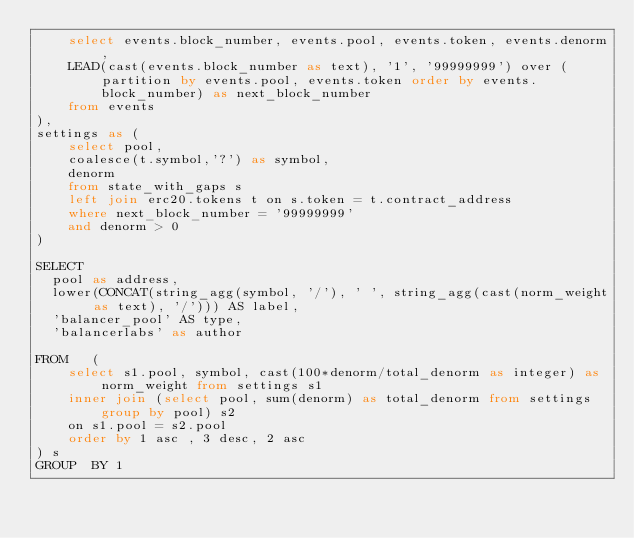<code> <loc_0><loc_0><loc_500><loc_500><_SQL_>    select events.block_number, events.pool, events.token, events.denorm,
    LEAD(cast(events.block_number as text), '1', '99999999') over (partition by events.pool, events.token order by events.block_number) as next_block_number
    from events 
), 
settings as (
    select pool, 
    coalesce(t.symbol,'?') as symbol, 
    denorm
    from state_with_gaps s
    left join erc20.tokens t on s.token = t.contract_address
    where next_block_number = '99999999'
    and denorm > 0
)

SELECT 
  pool as address, 
  lower(CONCAT(string_agg(symbol, '/'), ' ', string_agg(cast(norm_weight as text), '/'))) AS label,
  'balancer_pool' AS type,
  'balancerlabs' as author

FROM   (
    select s1.pool, symbol, cast(100*denorm/total_denorm as integer) as norm_weight from settings s1
    inner join (select pool, sum(denorm) as total_denorm from settings group by pool) s2
    on s1.pool = s2.pool
    order by 1 asc , 3 desc, 2 asc
) s
GROUP  BY 1
</code> 